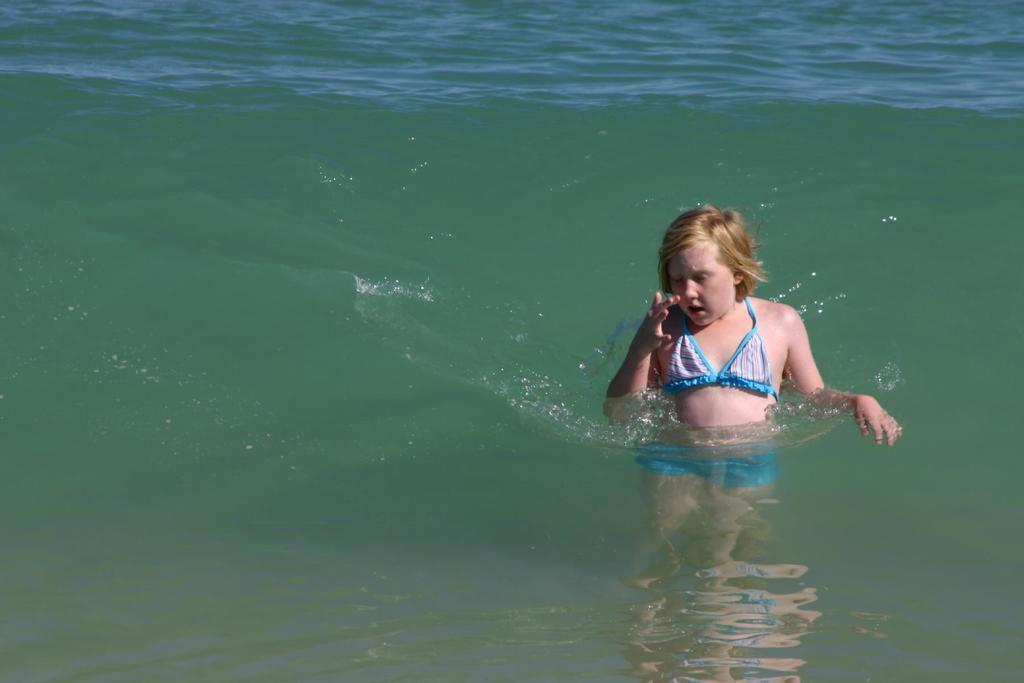Could you give a brief overview of what you see in this image? This image is taken outdoors. In this image there is a river with water. In the middle of the image there is a girl in the water. 